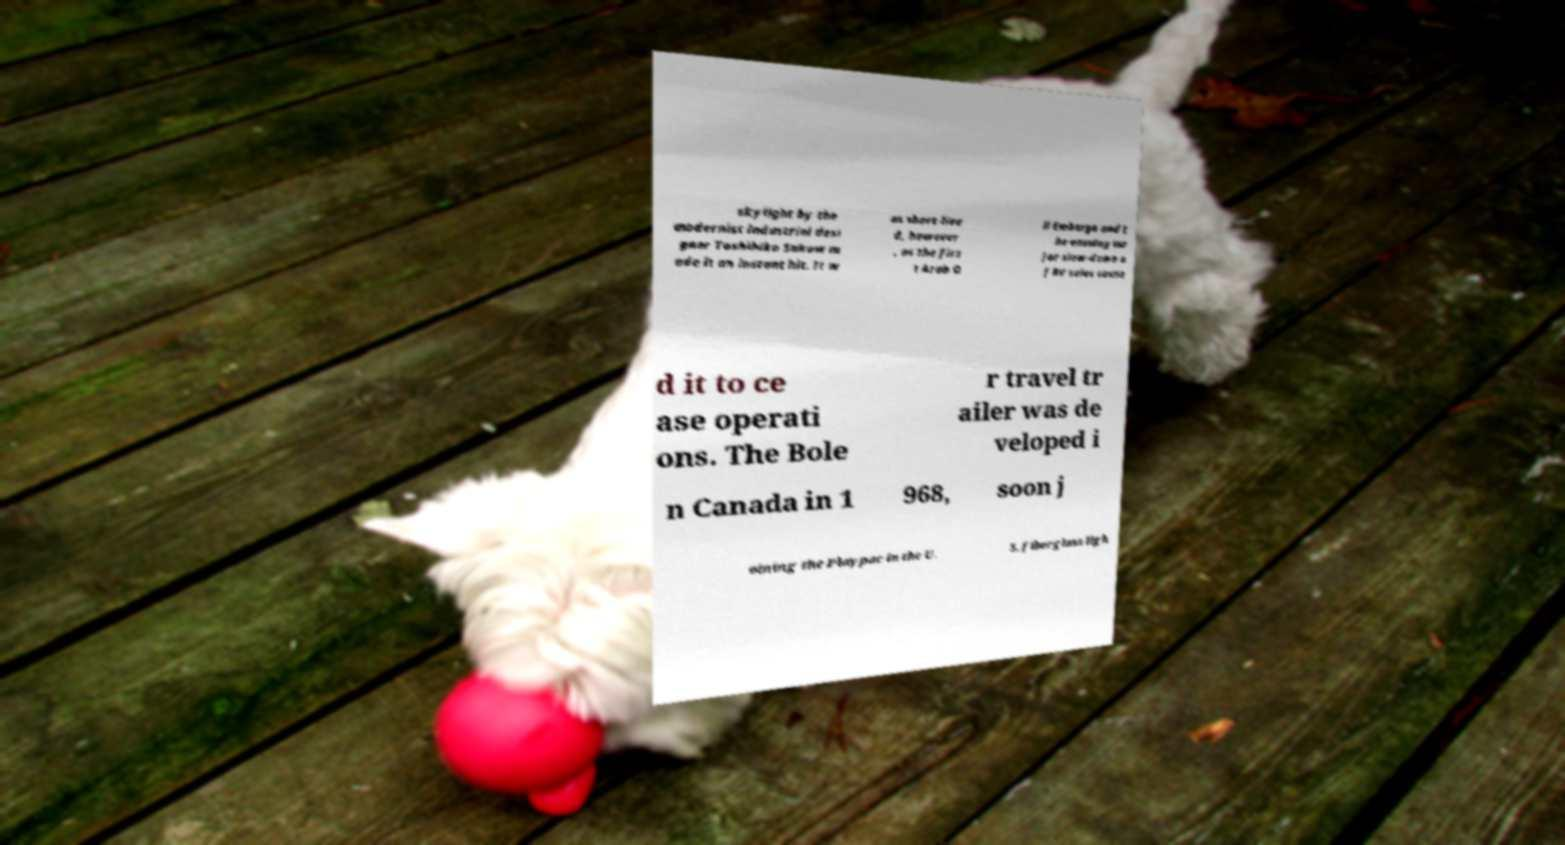Can you accurately transcribe the text from the provided image for me? skylight by the modernist industrial desi gner Toshihiko Sakow m ade it an instant hit. It w as short-live d, however , as the firs t Arab O il Embargo and t he ensuing ma jor slow-down o f RV sales cause d it to ce ase operati ons. The Bole r travel tr ailer was de veloped i n Canada in 1 968, soon j oining the Playpac in the U. S. fiberglass ligh 